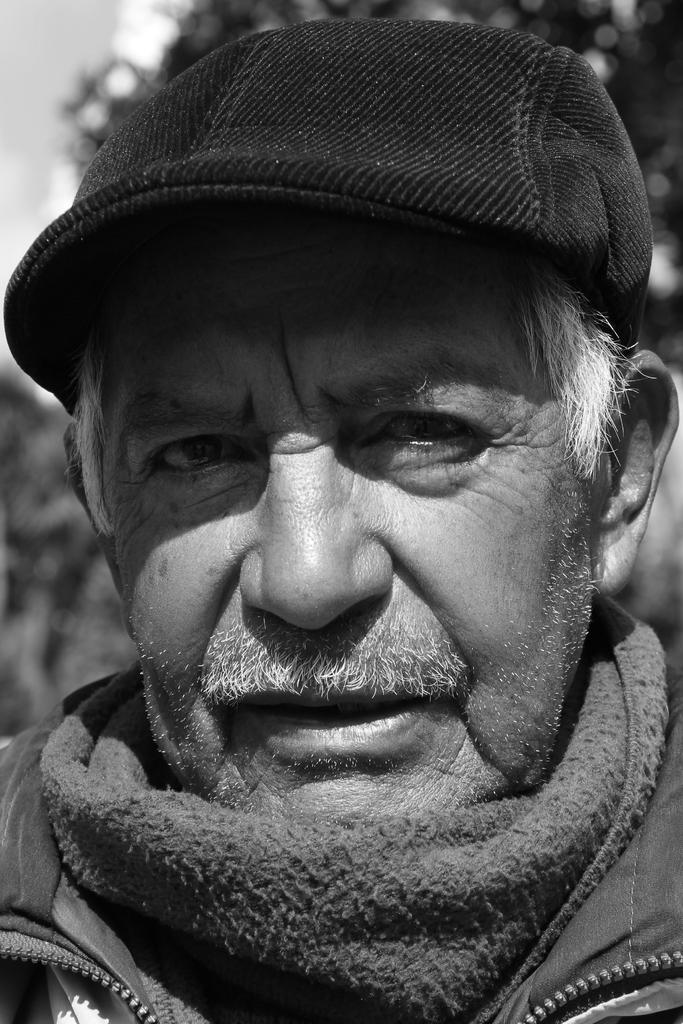What can be seen in the image? There is a person in the image. What is the person wearing? The person is wearing a jacket and a cap. Can you describe the background of the image? A: The background of the image is blurred. What is the color scheme of the image? The image is black and white. What type of carpenter tool can be seen in the image? There is no carpenter tool present in the image. What is the weather like during the recess in the image? There is no indication of a recess or weather in the image, as it only features a person wearing a jacket and cap with a blurred background. 